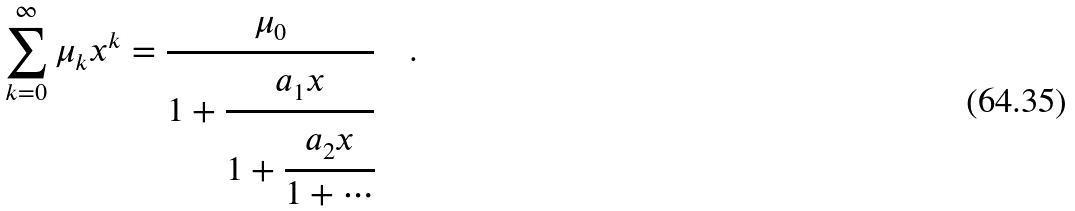Convert formula to latex. <formula><loc_0><loc_0><loc_500><loc_500>\sum _ { k = 0 } ^ { \infty } { \mu _ { k } } x ^ { k } = \cfrac { \mu _ { 0 } } { 1 + \cfrac { a _ { 1 } x } { 1 + \cfrac { a _ { 2 } x } { 1 + \cdots } } } \quad .</formula> 